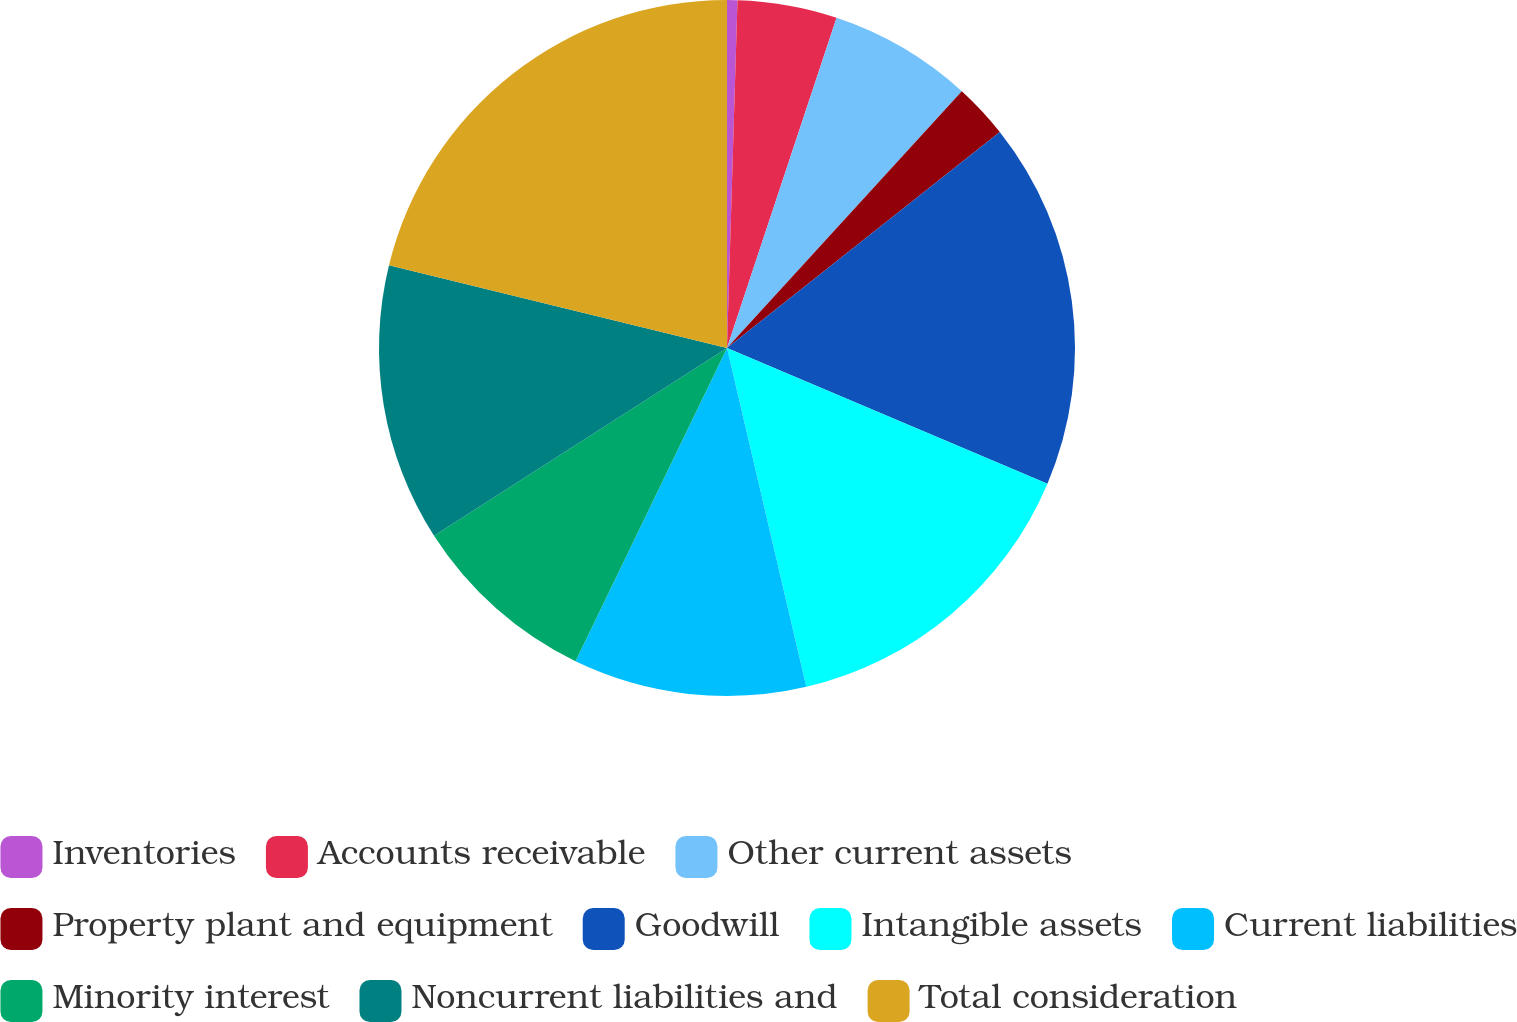Convert chart. <chart><loc_0><loc_0><loc_500><loc_500><pie_chart><fcel>Inventories<fcel>Accounts receivable<fcel>Other current assets<fcel>Property plant and equipment<fcel>Goodwill<fcel>Intangible assets<fcel>Current liabilities<fcel>Minority interest<fcel>Noncurrent liabilities and<fcel>Total consideration<nl><fcel>0.48%<fcel>4.62%<fcel>6.69%<fcel>2.55%<fcel>17.04%<fcel>14.97%<fcel>10.83%<fcel>8.76%<fcel>12.9%<fcel>21.18%<nl></chart> 